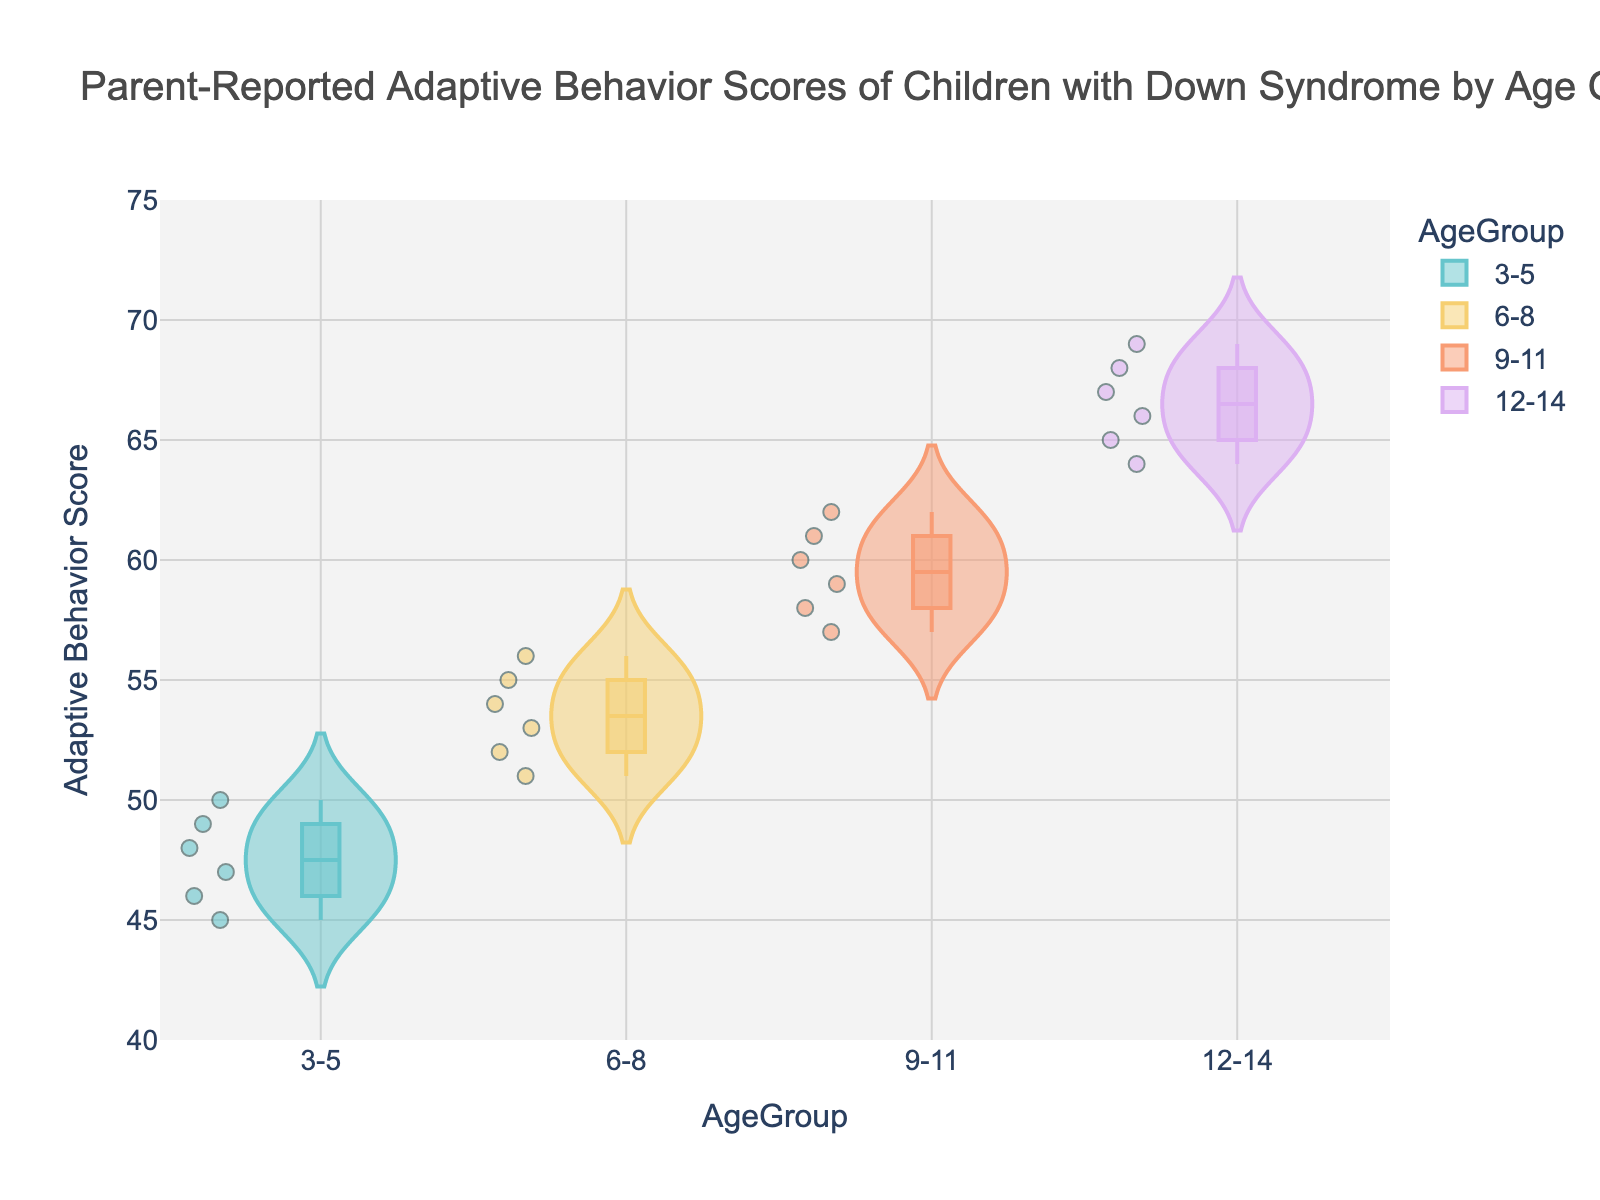What's the title of the figure? The title of the figure is usually found at the top and is written in a larger or bold font.
Answer: Parent-Reported Adaptive Behavior Scores of Children with Down Syndrome by Age Group How many age groups are represented in the figure? By looking at the x-axis, we can see the number of distinct categories mentioned.
Answer: Four Which age group has the highest median adaptive behavior score? The median is represented by a horizontal line inside each violin plot. Find the highest median line.
Answer: 12-14 What is the range of adaptive behavior scores for the 6-8 age group? The range is the difference between the maximum and minimum values seen in the violin plot for the 6-8 age group.
Answer: 51 to 56 Do younger children (3-5) tend to have lower scores than older children (12-14)? Visually compare the overall shape and position of the violin plots. Scores of younger children are generally lower than older children.
Answer: Yes Which age group shows the most variability in adaptive behavior scores? Variability can be judged by the width of the violin plot's spread. The wider the spread, the more variability.
Answer: 9-11 How do the adaptive behavior scores of children aged 3-5 compare to those aged 6-8? Compare the violin plots of the two age groups in terms of range, median, and spread.
Answer: 6-8 scores are generally higher and show more spread than 3-5 What is the interquartile range (IQR) for the 12-14 age group's adaptive behavior scores? The IQR is the range within the box of the box plot within the violin plot. Find the upper quartile minus the lower quartile inside the box.
Answer: 4 Are there any outliers in the data? Outliers are typically represented by points outside the main body of the violin plot and box plot.
Answer: No What is the average score of the children aged 9-11? Sum the scores in the 9-11 group and divide by the number of scores.
Answer: (58+60+59+61+57+62)/6 = 59.5 